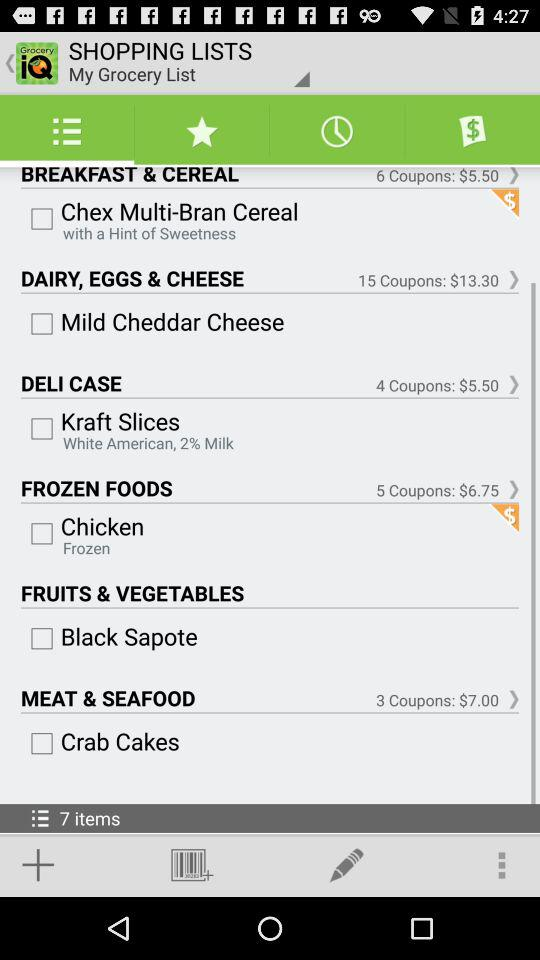Crab cakes are an item available on which grocery list? The crab cakes are available on the meat and seafood list. 